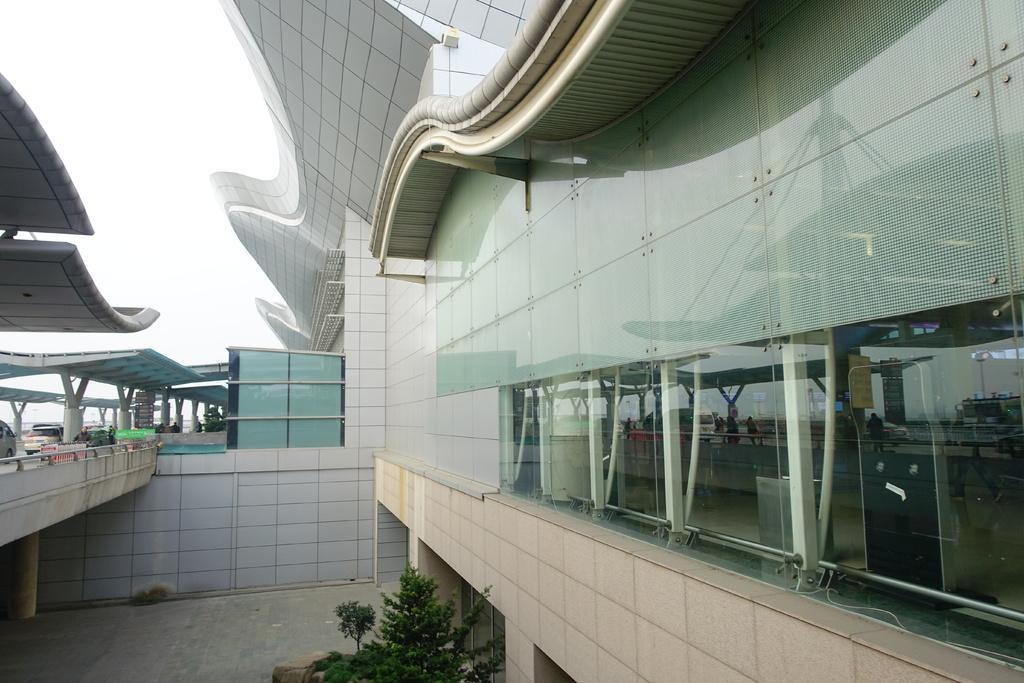What type of building is in the image? There is an airport glass building with a metal frame in the image. What can be seen from the building? The building has a view. What structure is on the right side of the image? There is a concrete bridge on the right side of the image. Is there anything on top of the bridge? Yes, there is a shed on the top of the bridge. What type of peace can be seen in the image? There is no reference to peace in the image; it features an airport glass building, a concrete bridge, and a shed. How does the image look in terms of profit? The image does not convey any information about profit; it is a visual representation of a building, a bridge, and a shed. 